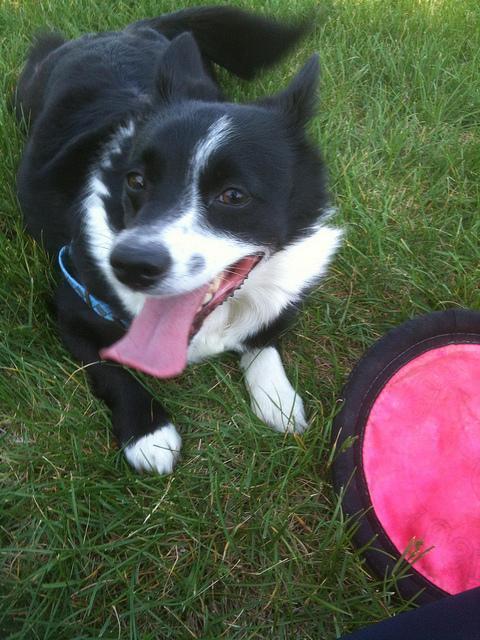How many frisbees can you see?
Give a very brief answer. 1. How many people are wearing hats?
Give a very brief answer. 0. 